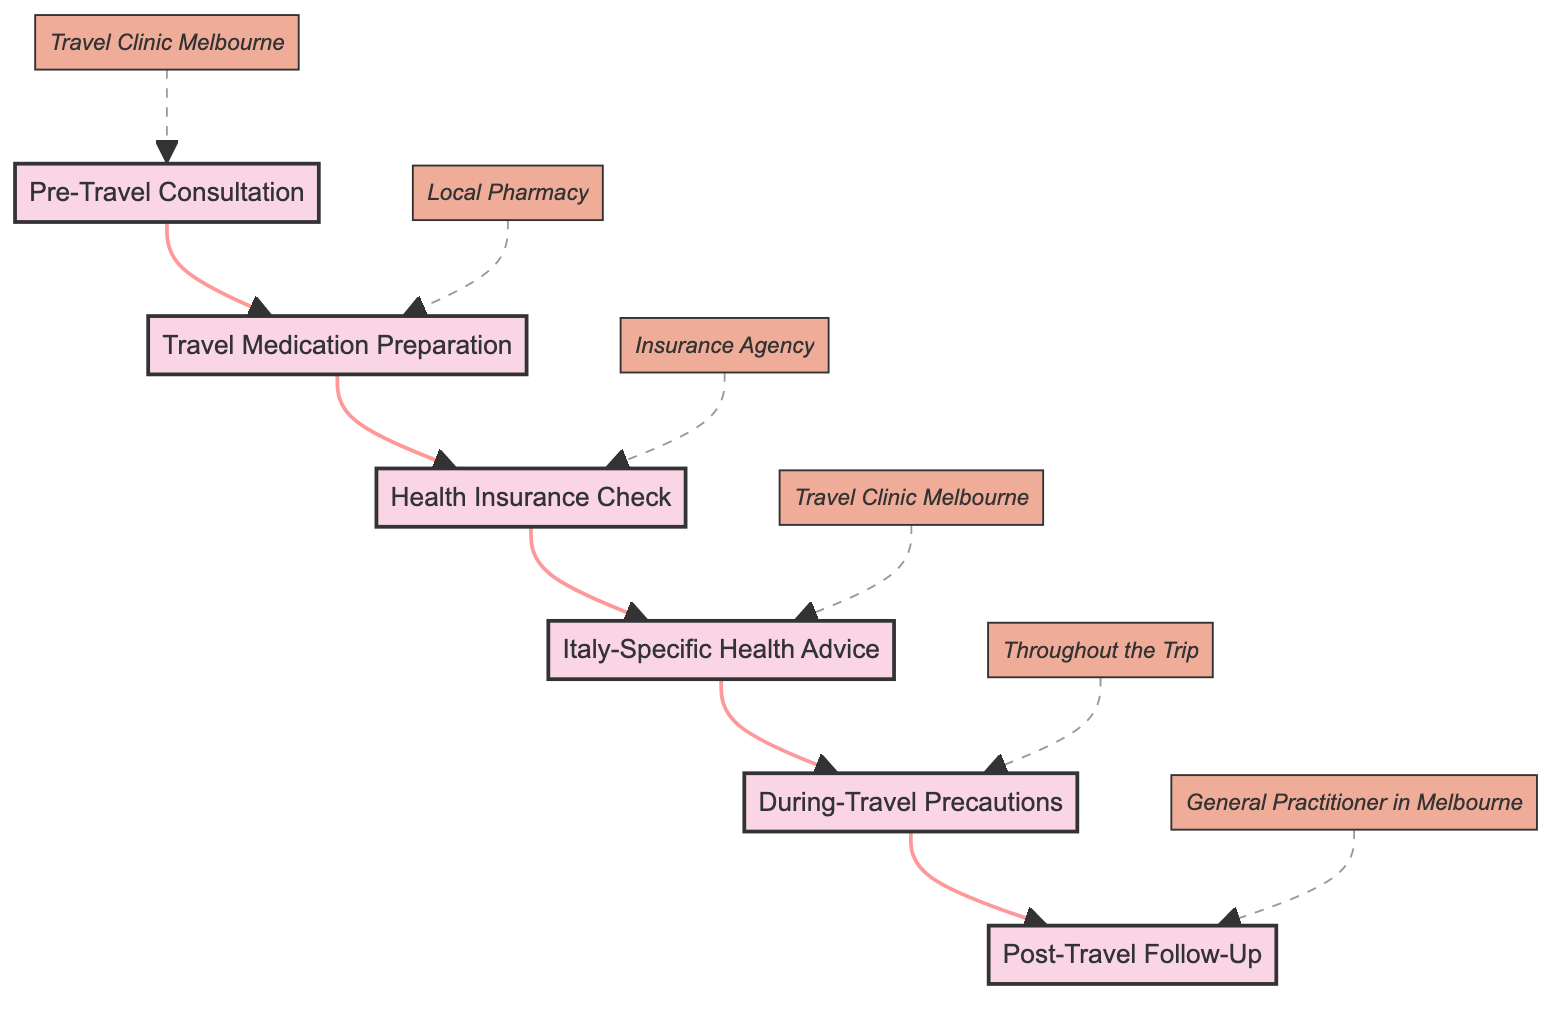What is the first step in the pathway? The diagram lists "Pre-Travel Consultation" as the first node in the sequence, indicating it is the starting point of the clinical pathway.
Answer: Pre-Travel Consultation How many steps are in the clinical pathway? By counting the distinct steps present in the diagram, we see there are six labeled steps from "Pre-Travel Consultation" to "Post-Travel Follow-Up."
Answer: 6 What is the location for the "Health Insurance Check"? The diagram indicates "Insurance Agency" as the designated location for the "Health Insurance Check" step.
Answer: Insurance Agency Which step follows "Travel Medication Preparation"? The pathway shows that the "Health Insurance Check" step directly follows "Travel Medication Preparation" as the next node in the flow.
Answer: Health Insurance Check What components are included in the "Italy-Specific Health Advice"? The node for "Italy-Specific Health Advice" lists three components: "Regional Health Risks," "Local Emergency Numbers," and "Safe Drinking Water Practices."
Answer: Regional Health Risks, Local Emergency Numbers, Safe Drinking Water Practices What are the locations for the steps that occur in a Travel Clinic? The diagram indicates that "Pre-Travel Consultation" and "Italy-Specific Health Advice" are conducted at "Travel Clinic Melbourne."
Answer: Travel Clinic Melbourne What is the last precaution suggested during travel? The "During-Travel Precautions" step includes "Jet Lag Management" as one of the advice components, noting it as part of the last stage before the follow-up.
Answer: Jet Lag Management Which step involves a follow-up check after returning from travel? As per the pathway, the final step is "Post-Travel Follow-Up," which signifies a health assessment after the trip.
Answer: Post-Travel Follow-Up 